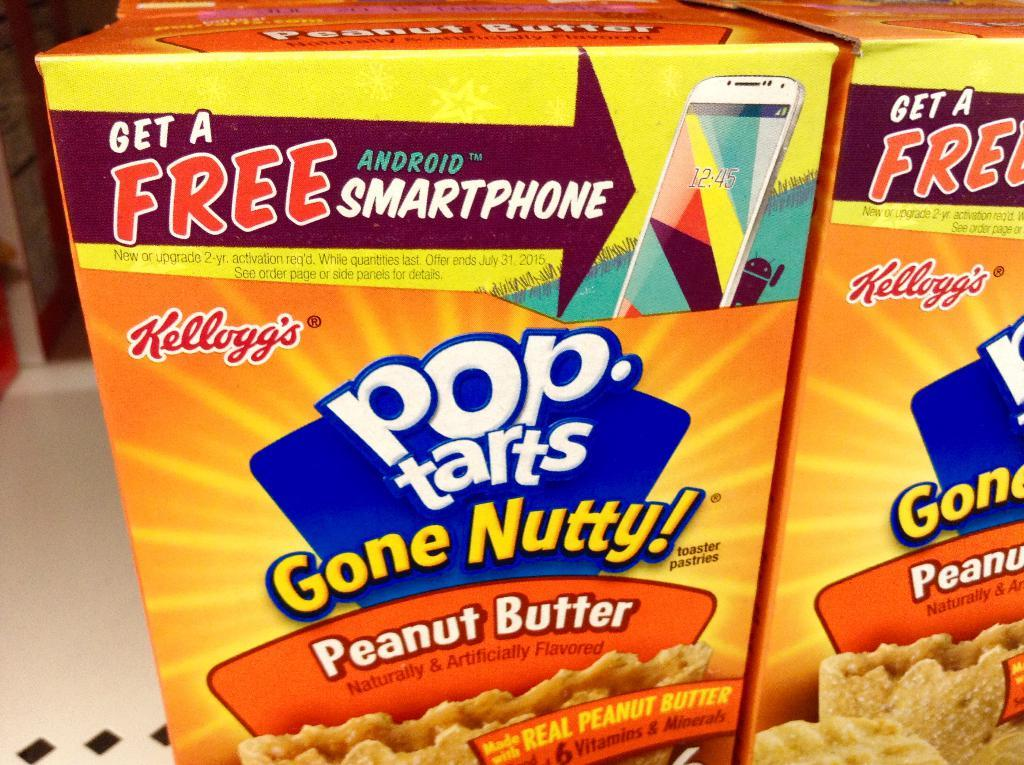<image>
Share a concise interpretation of the image provided. The box of Pop Tarts advertises a free android smartphone. 